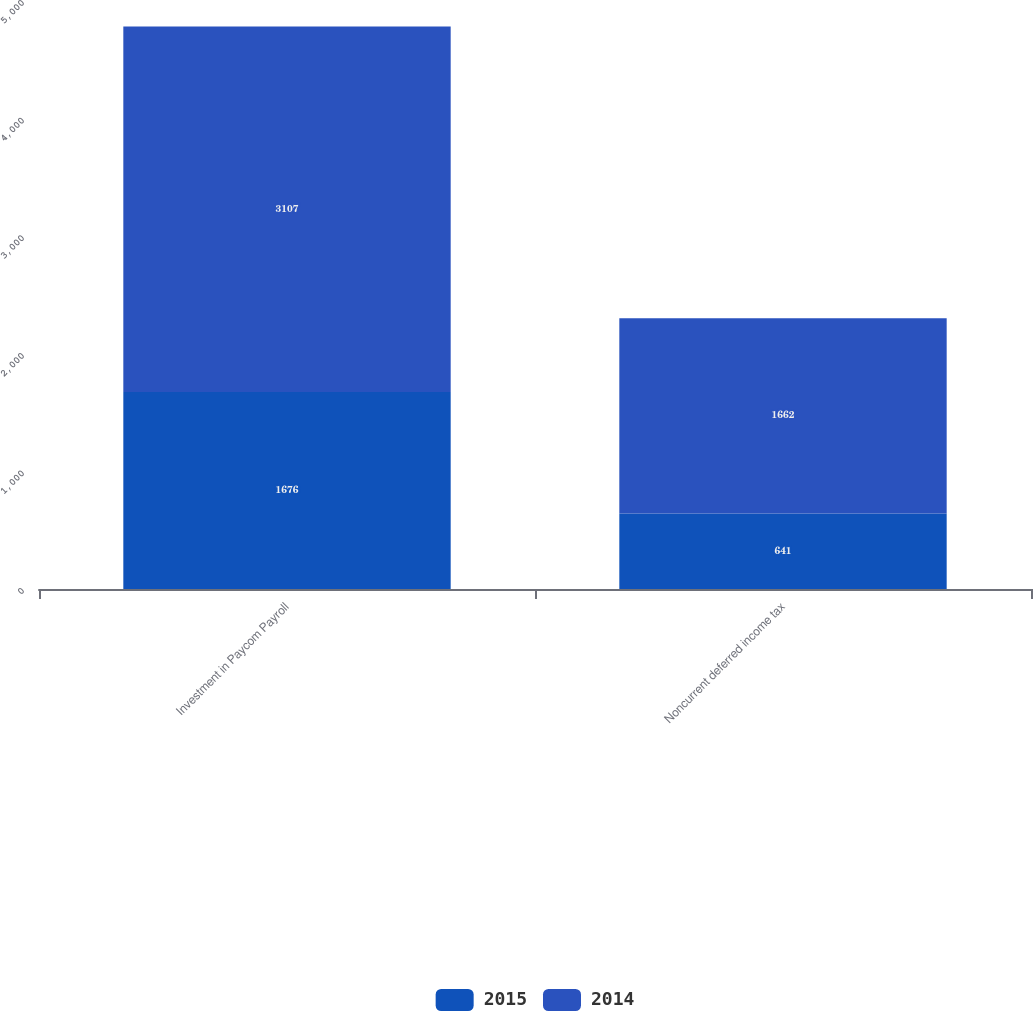Convert chart. <chart><loc_0><loc_0><loc_500><loc_500><stacked_bar_chart><ecel><fcel>Investment in Paycom Payroll<fcel>Noncurrent deferred income tax<nl><fcel>2015<fcel>1676<fcel>641<nl><fcel>2014<fcel>3107<fcel>1662<nl></chart> 